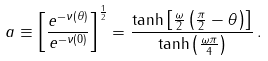Convert formula to latex. <formula><loc_0><loc_0><loc_500><loc_500>a \equiv \left [ \frac { e ^ { - \nu ( \theta ) } } { e ^ { - \nu ( 0 ) } } \right ] ^ { \frac { 1 } { 2 } } = \frac { \tanh \left [ \frac { \omega } { 2 } \left ( \frac { \pi } { 2 } - \theta \right ) \right ] } { \tanh \left ( \frac { \omega \pi } { 4 } \right ) } \, .</formula> 